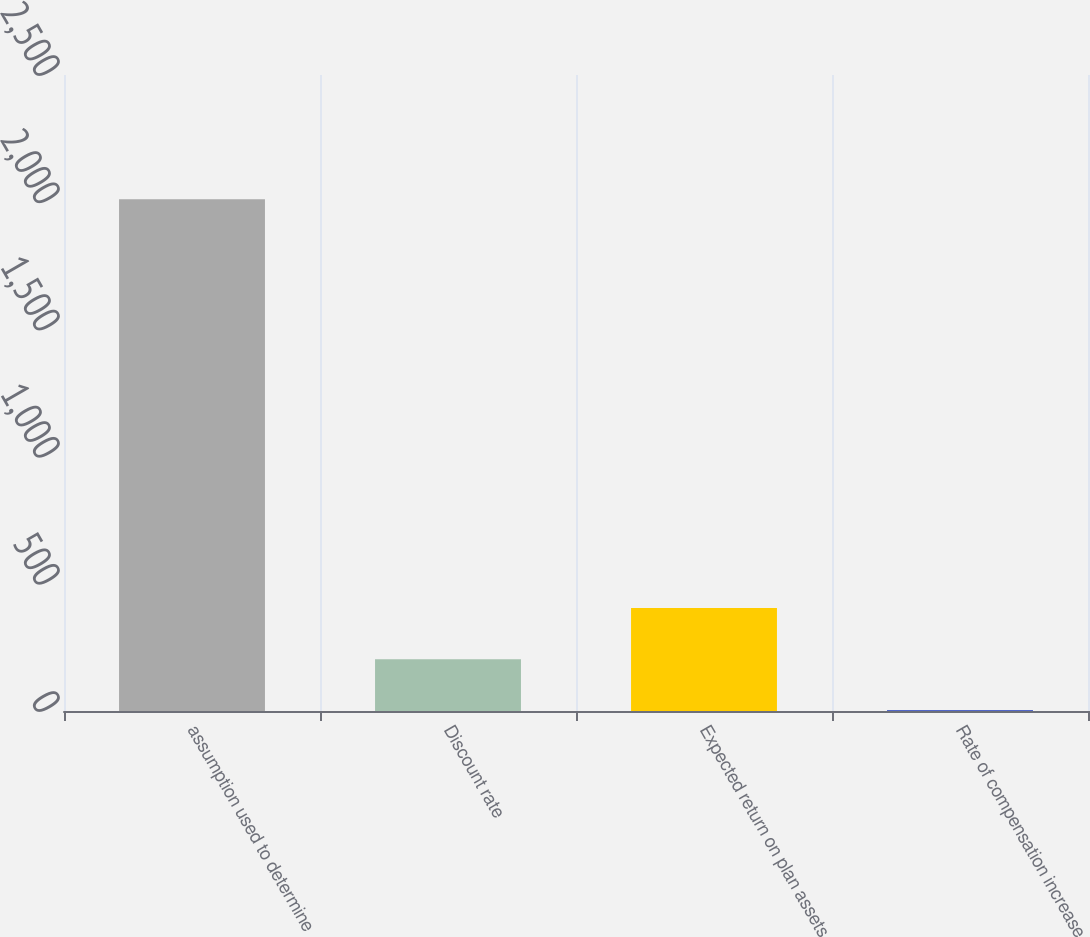Convert chart to OTSL. <chart><loc_0><loc_0><loc_500><loc_500><bar_chart><fcel>assumption used to determine<fcel>Discount rate<fcel>Expected return on plan assets<fcel>Rate of compensation increase<nl><fcel>2012<fcel>203.79<fcel>404.7<fcel>2.88<nl></chart> 